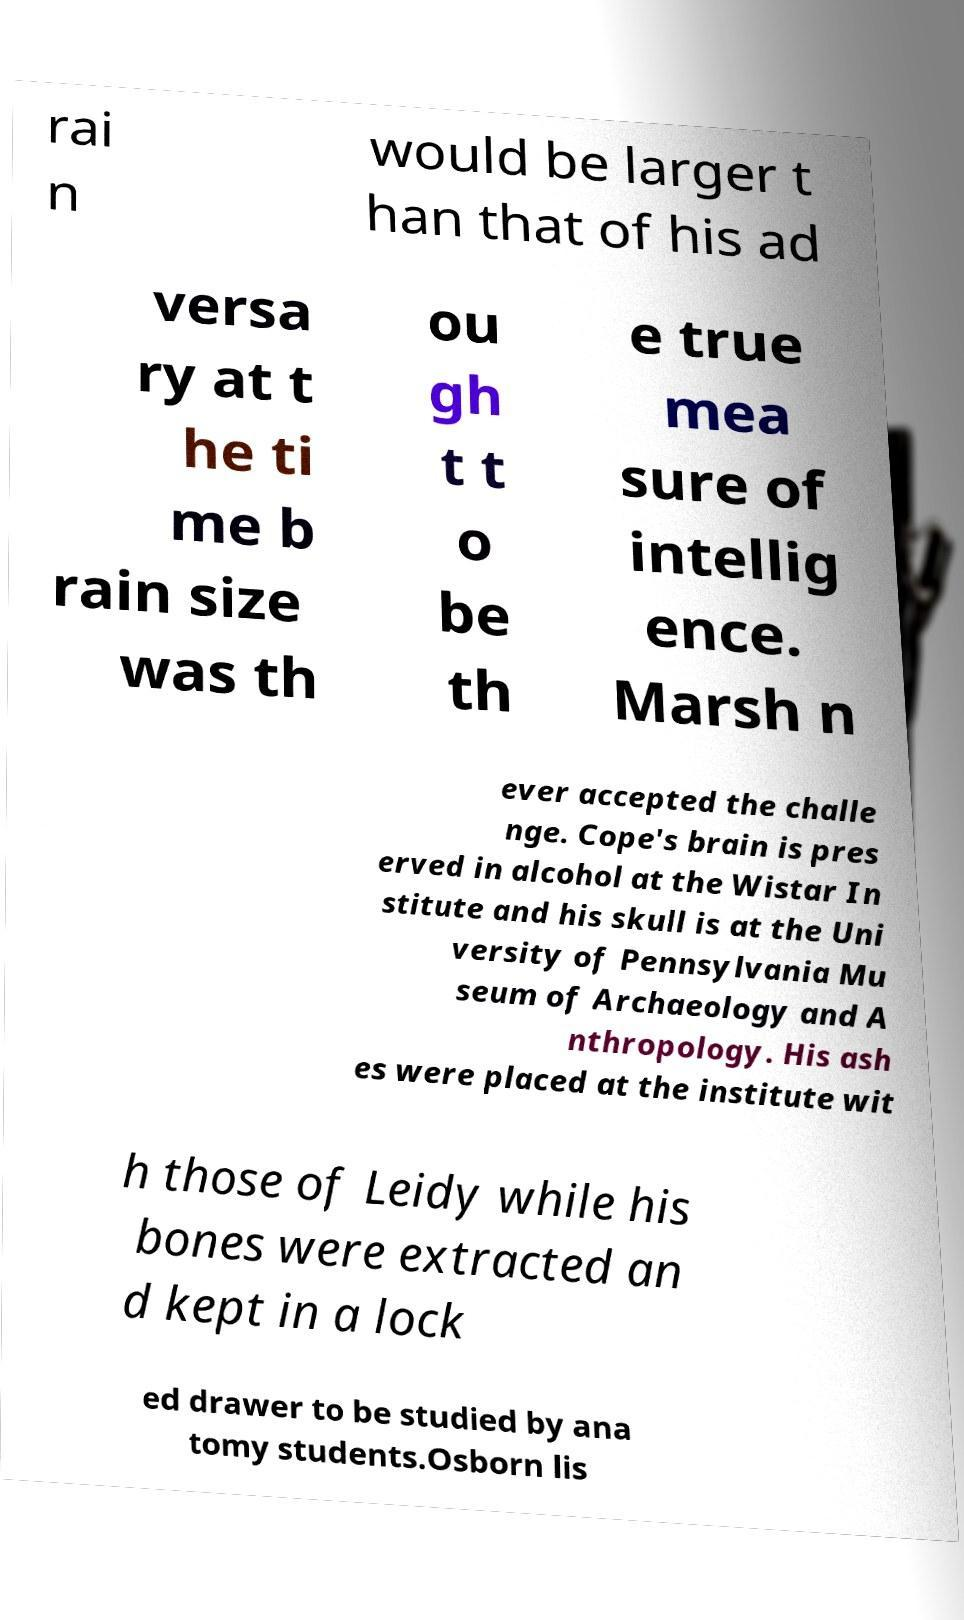Can you read and provide the text displayed in the image?This photo seems to have some interesting text. Can you extract and type it out for me? rai n would be larger t han that of his ad versa ry at t he ti me b rain size was th ou gh t t o be th e true mea sure of intellig ence. Marsh n ever accepted the challe nge. Cope's brain is pres erved in alcohol at the Wistar In stitute and his skull is at the Uni versity of Pennsylvania Mu seum of Archaeology and A nthropology. His ash es were placed at the institute wit h those of Leidy while his bones were extracted an d kept in a lock ed drawer to be studied by ana tomy students.Osborn lis 